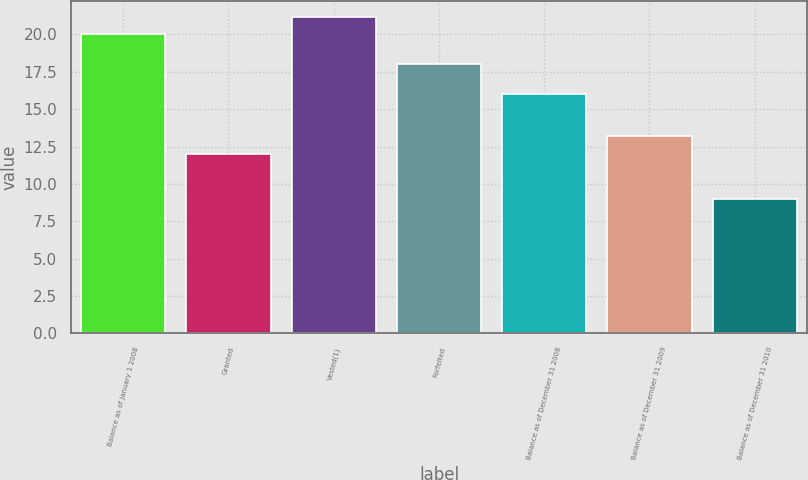Convert chart. <chart><loc_0><loc_0><loc_500><loc_500><bar_chart><fcel>Balance as of January 1 2008<fcel>Granted<fcel>Vested(1)<fcel>Forfeited<fcel>Balance as of December 31 2008<fcel>Balance as of December 31 2009<fcel>Balance as of December 31 2010<nl><fcel>20<fcel>12<fcel>21.2<fcel>18<fcel>16<fcel>13.2<fcel>9<nl></chart> 